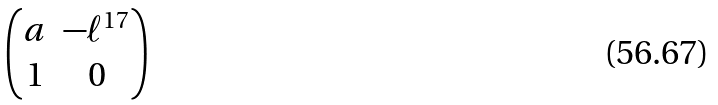Convert formula to latex. <formula><loc_0><loc_0><loc_500><loc_500>\begin{pmatrix} a & - \ell ^ { 1 7 } \\ 1 & 0 \end{pmatrix}</formula> 